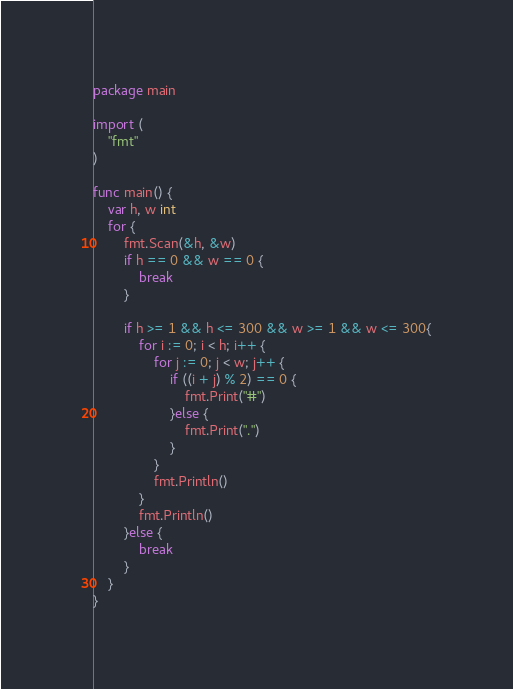<code> <loc_0><loc_0><loc_500><loc_500><_Go_>package main

import (
	"fmt"
)

func main() {
	var h, w int
	for {
		fmt.Scan(&h, &w)
		if h == 0 && w == 0 { 
			break
		}
		
		if h >= 1 && h <= 300 && w >= 1 && w <= 300{
			for i := 0; i < h; i++ {
				for j := 0; j < w; j++ {
					if ((i + j) % 2) == 0 {
						fmt.Print("#")
					}else {
						fmt.Print(".")
					}
				}
				fmt.Println()
			}
			fmt.Println()
		}else {
			break
		}
	}
}
</code> 